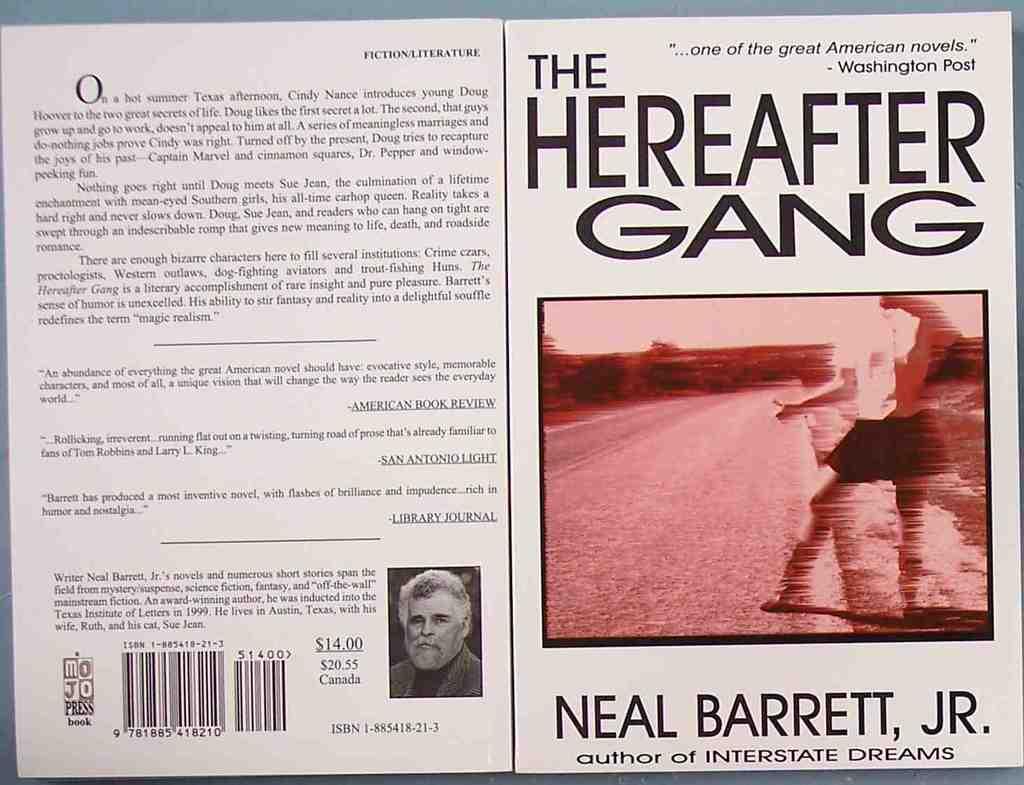Who is the author of this book?
Your answer should be compact. Neal barrett, jr. What gang is this book about?
Make the answer very short. Hereafter. 